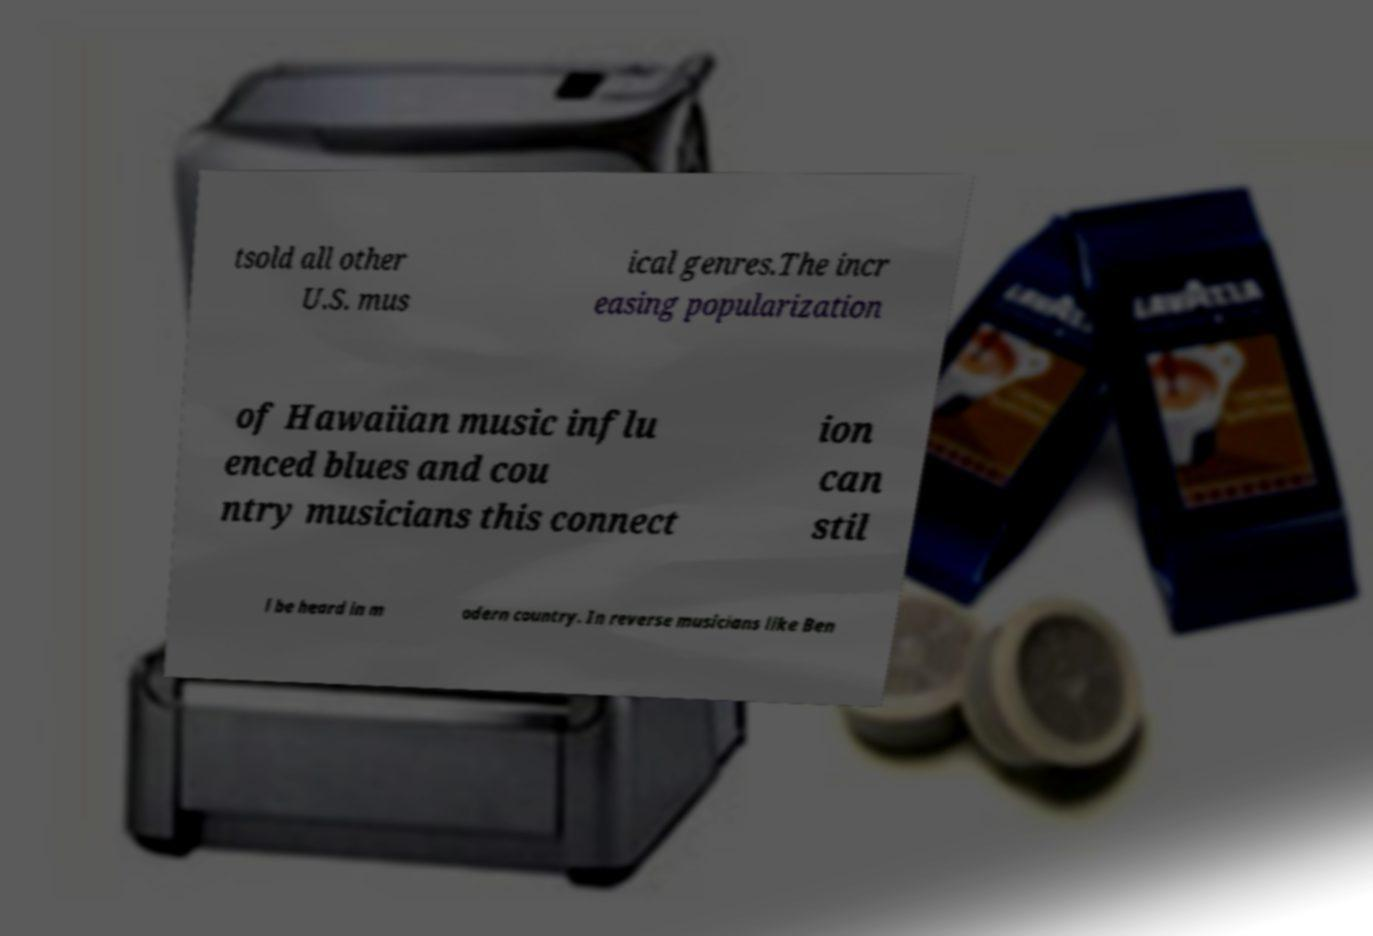What messages or text are displayed in this image? I need them in a readable, typed format. tsold all other U.S. mus ical genres.The incr easing popularization of Hawaiian music influ enced blues and cou ntry musicians this connect ion can stil l be heard in m odern country. In reverse musicians like Ben 